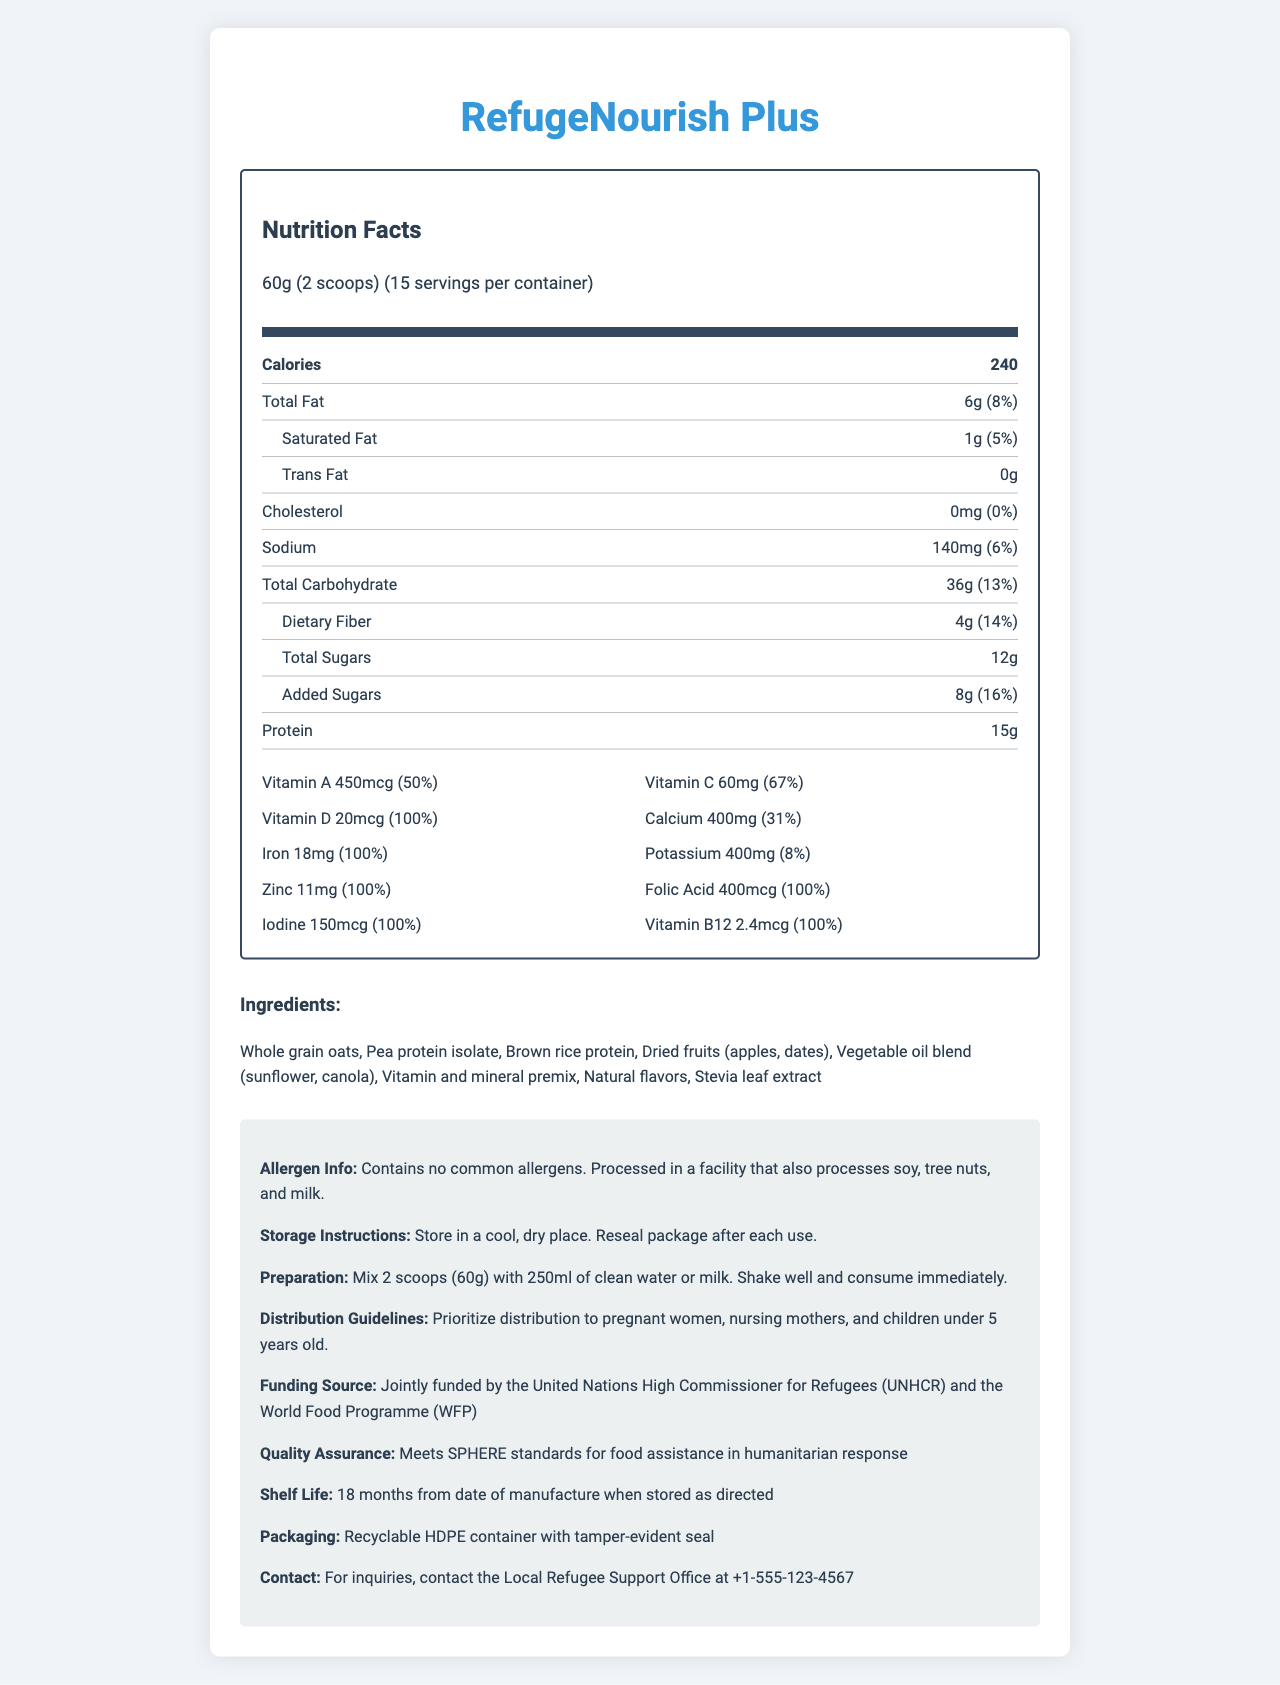how many servings does the RefugeNourish Plus container hold? The document mentions that there are 15 servings per container.
Answer: 15 how much protein is in one serving of RefugeNourish Plus? The document specifies that each serving contains 15g of protein.
Answer: 15g What is the serving size for RefugeNourish Plus? The serving size is listed as 60g, which equals 2 scoops.
Answer: 60g (2 scoops) What percentage of the daily value of Vitamin C does one serving of RefugeNourish Plus provide? One serving provides 67% of the daily value of Vitamin C, according to the document.
Answer: 67% What is the preparation instruction for RefugeNourish Plus? The preparation instructions clearly state to mix 2 scoops (60g) with 250ml of clean water or milk, shake well, and consume immediately.
Answer: Mix 2 scoops (60g) with 250ml of clean water or milk. Shake well and consume immediately. Who should be prioritized for the distribution of RefugeNourish Plus? The distribution guidelines specify that these groups should be prioritized.
Answer: Pregnant women, nursing mothers, and children under 5 years old What is the total fat content in one serving of RefugeNourish Plus? The document indicates that one serving contains 6g of total fat.
Answer: 6g RefugeNourish Plus is primarily funded by which organizations? A. UNICEF and WHO B. United Nations High Commissioner for Refugees and the World Food Programme C. Red Cross and Red Crescent The funding source section states that the product is jointly funded by the United Nations High Commissioner for Refugees (UNHCR) and the World Food Programme (WFP).
Answer: B. United Nations High Commissioner for Refugees and the World Food Programme How much added sugar does each serving of RefugeNourish Plus contain? Each serving contains 8g of added sugars, according to the document.
Answer: 8g What type of container is used for packaging RefugeNourish Plus? The packaging information specifies that a recyclable HDPE container with a tamper-evident seal is used.
Answer: Recyclable HDPE container with tamper-evident seal What is the shelf life of RefugeNourish Plus? The document mentions that the shelf life is 18 months if stored as directed.
Answer: 18 months from date of manufacture when stored as directed What is a key quality assurance standard met by RefugeNourish Plus? A. GMP standards B. SPHERE standards C. FDA regulations The quality assurance section mentions that RefugeNourish Plus meets SPHERE standards for food assistance in humanitarian response.
Answer: B. SPHERE standards What vitamins and minerals in RefugeNourish Plus are provided at 100% of daily value per serving? (Select all that apply) i. Vitamin D ii. Calcium iii. Iron iv. Iodine v. Zinc The vitamins and minerals that are provided at 100% daily value per serving include Vitamin D, Iron, Iodine, and Zinc as per the document.
Answer: i, iii, iv, v Does RefugeNourish Plus contain any common allergens? The allergen info indicates that the product contains no common allergens.
Answer: No Provide a summary of the RefugeNourish Plus nutrition facts label. This summary condenses the key elements of the document, including nutritional values, preparation instructions, target beneficiaries, packaging, shelf life, and funding sources.
Answer: The RefugeNourish Plus nutrition facts label provides detailed information on the nutritional content of the fortified food supplement. Each serving size is 60g (2 scoops), with 240 calories per serving. The product is rich in protein (15g) and contains essential vitamins and minerals, with 100% daily value of Vitamin D, Iron, Zinc, Folic Acid, Iodine, and Vitamin B12. It is free from common allergens and is packaged in a recyclable HDPE container. The product meets SPHERE standards for humanitarian food assistance and has an 18-month shelf life. It is intended to address common nutritional deficiencies, particularly prioritizing pregnant women, nursing mothers, and young children. The preparation instructions involve mixing with water or milk, and it is jointly funded by the UNHCR and WFP. At what temperature should RefugeNourish Plus be stored? The storage instructions mention storing in a cool, dry place but do not specify an exact temperature.
Answer: Not specified 